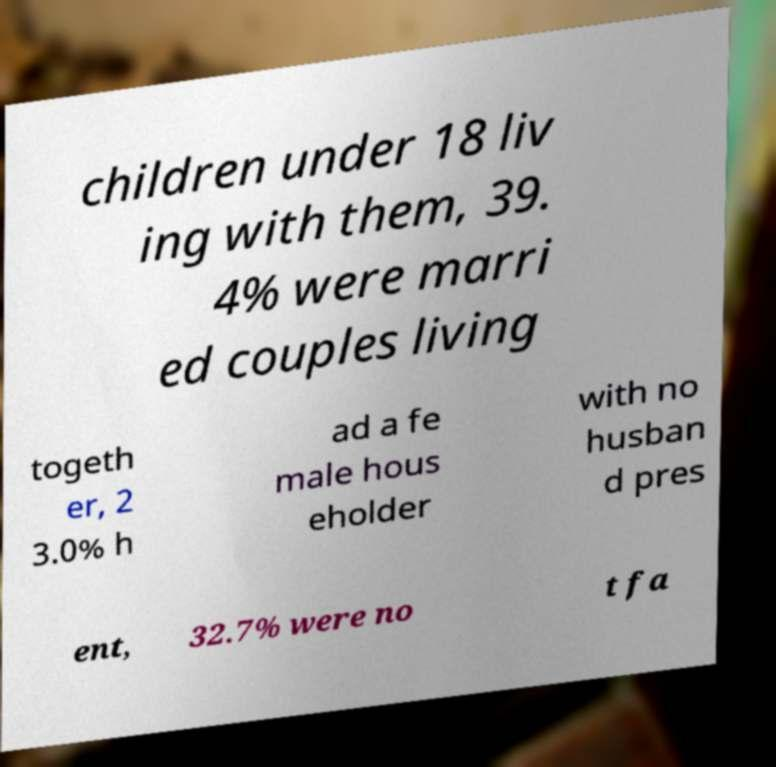Please identify and transcribe the text found in this image. children under 18 liv ing with them, 39. 4% were marri ed couples living togeth er, 2 3.0% h ad a fe male hous eholder with no husban d pres ent, 32.7% were no t fa 